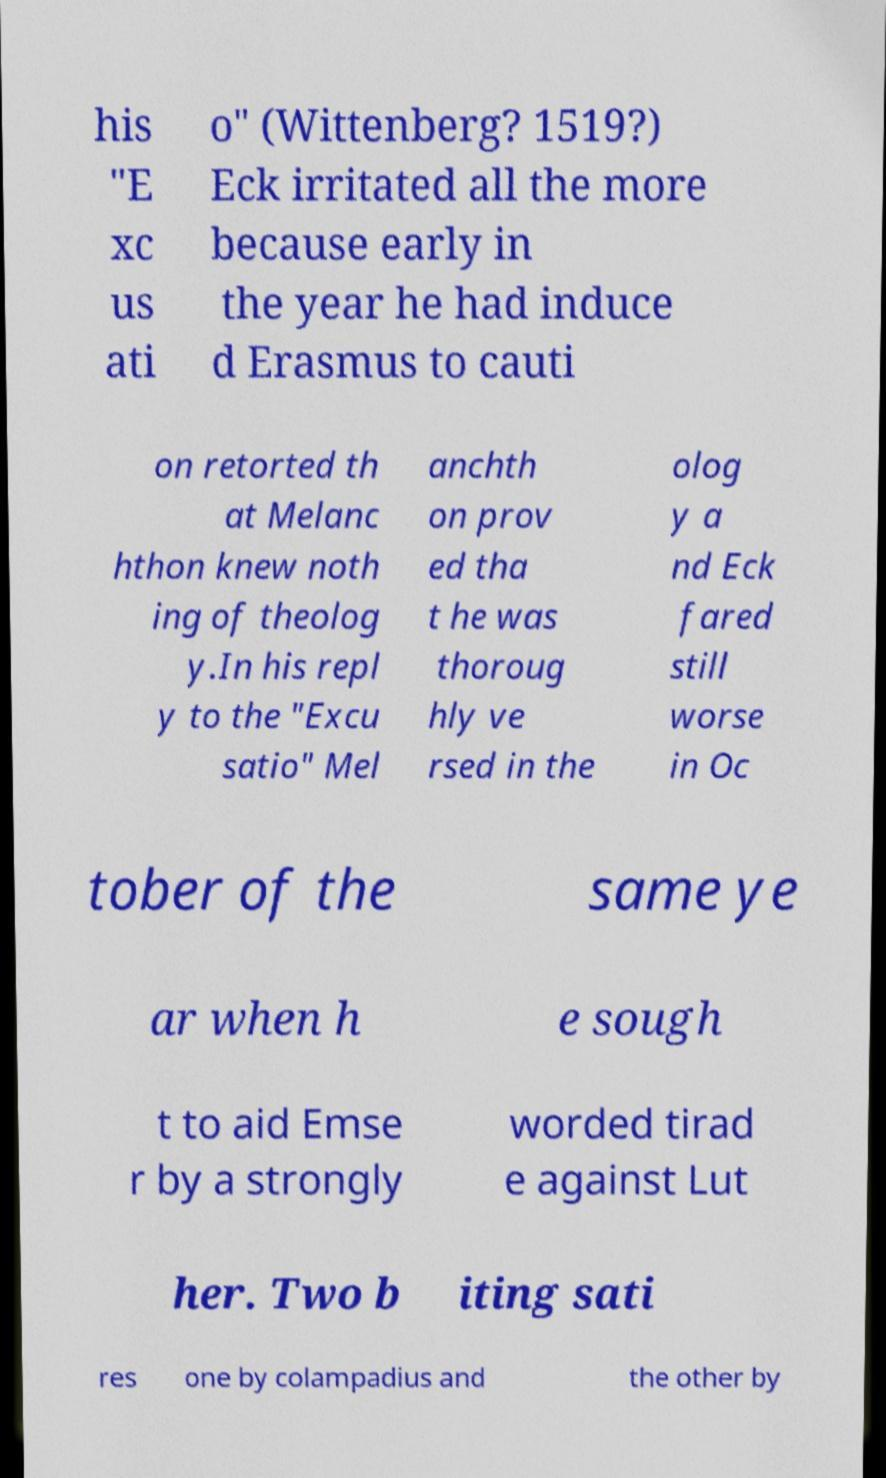Can you read and provide the text displayed in the image?This photo seems to have some interesting text. Can you extract and type it out for me? his "E xc us ati o" (Wittenberg? 1519?) Eck irritated all the more because early in the year he had induce d Erasmus to cauti on retorted th at Melanc hthon knew noth ing of theolog y.In his repl y to the "Excu satio" Mel anchth on prov ed tha t he was thoroug hly ve rsed in the olog y a nd Eck fared still worse in Oc tober of the same ye ar when h e sough t to aid Emse r by a strongly worded tirad e against Lut her. Two b iting sati res one by colampadius and the other by 